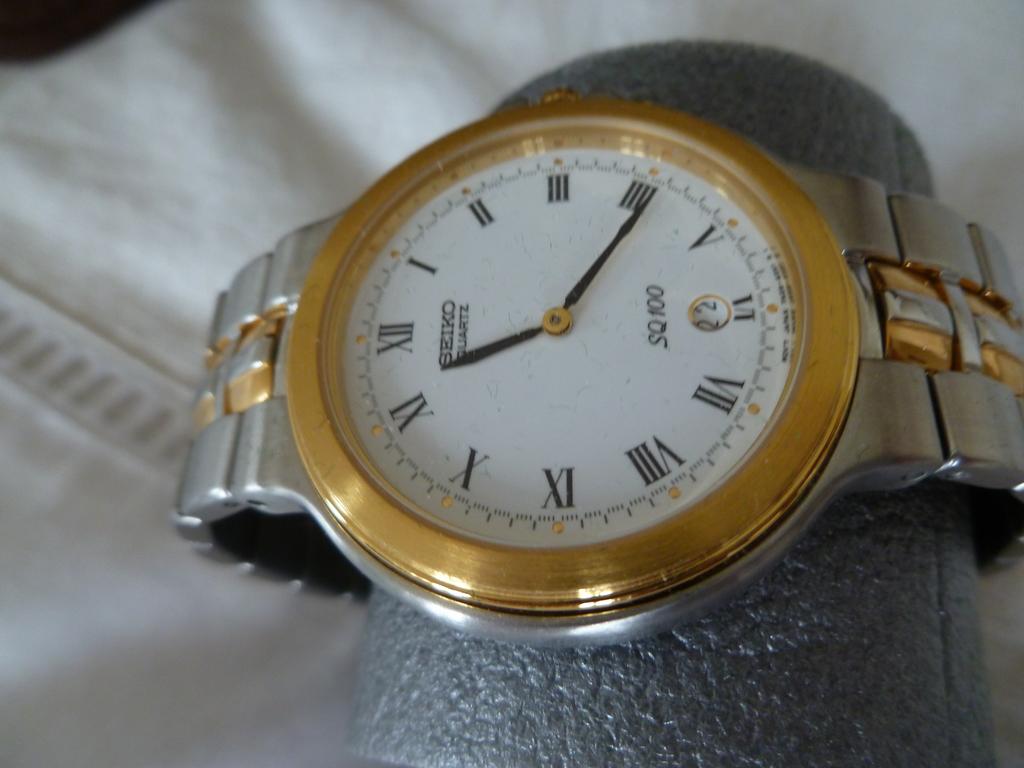What is the brand of this watch?
Your response must be concise. Seiko. What time is it?
Give a very brief answer. 11:21. 